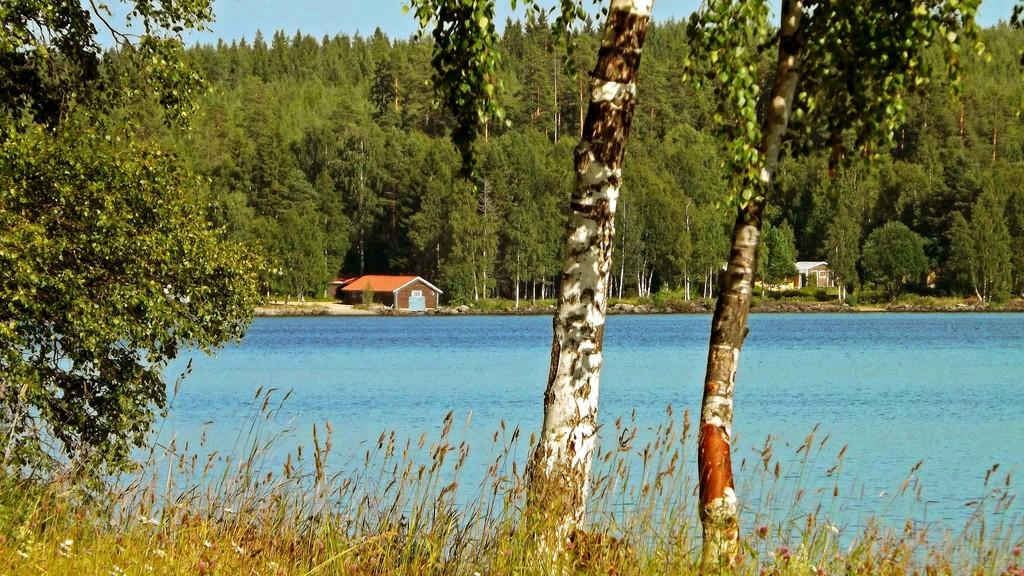What type of vegetation is in the foreground of the image? There are trees and grass in the foreground of the image. What can be seen in the background of the image? There is water, houses, trees, and the sky visible in the background of the image. How many dimes are scattered on the grass in the image? There are no dimes present in the image; it features trees and grass in the foreground. What type of bag is being carried by the secretary in the image? There is no secretary or bag present in the image. 